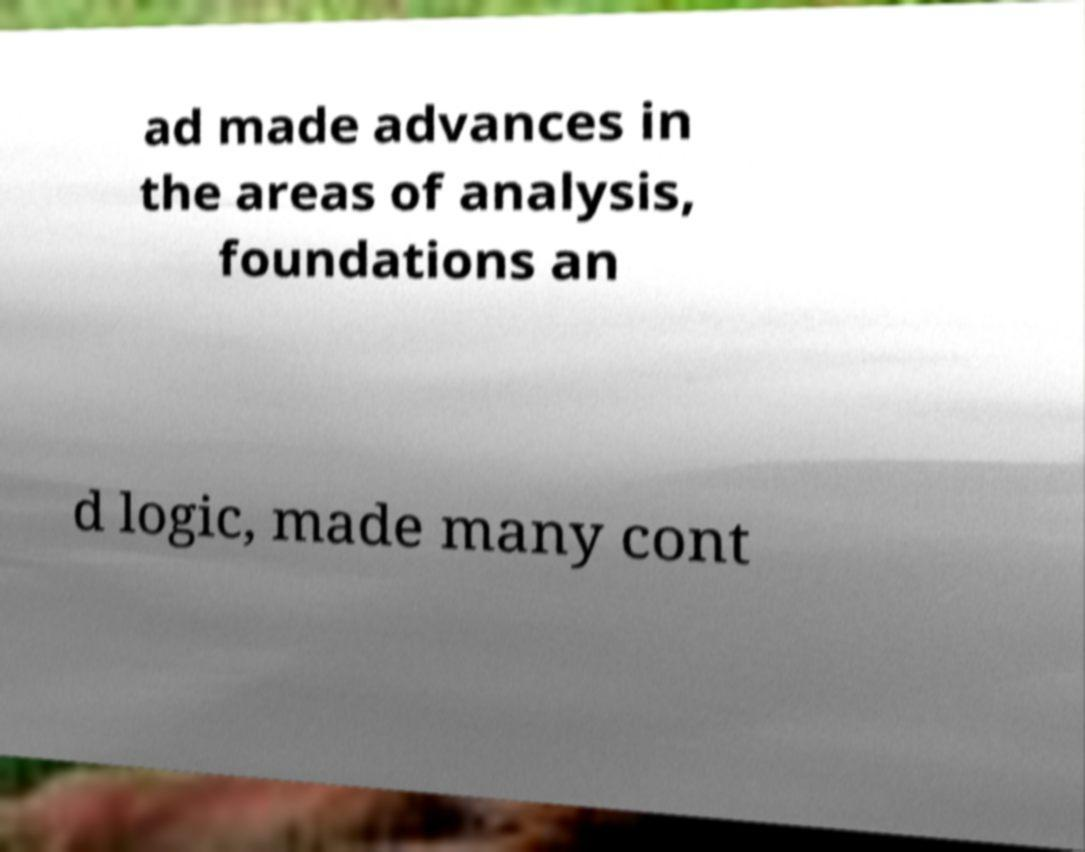Please read and relay the text visible in this image. What does it say? ad made advances in the areas of analysis, foundations an d logic, made many cont 